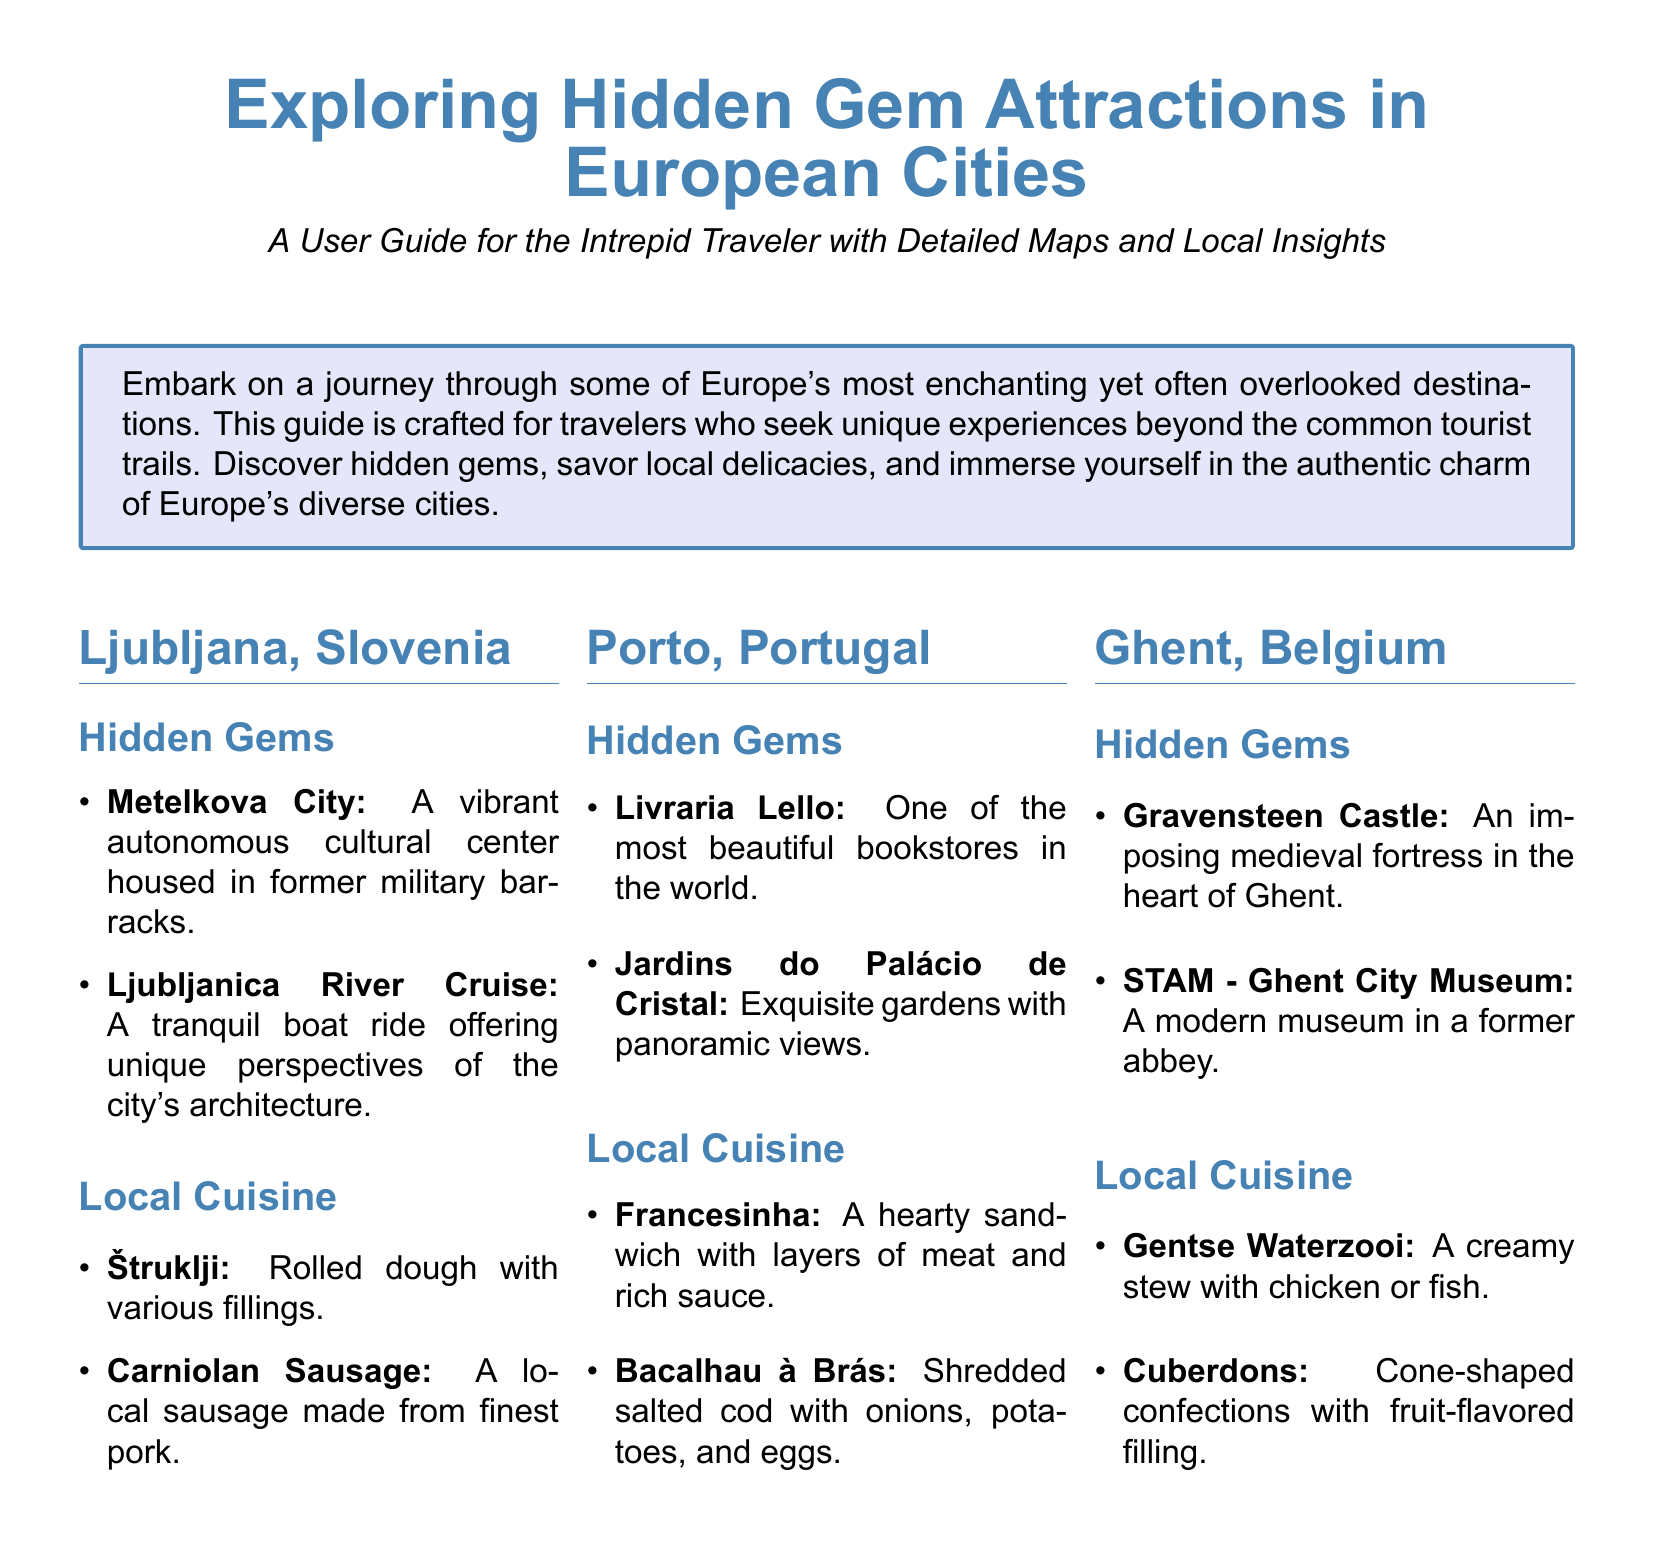What is the cultural center in Ljubljana? The document states that Metelkova City is a vibrant autonomous cultural center in Ljubljana.
Answer: Metelkova City What type of dish is Štruklji? Štruklji is described as rolled dough with various fillings.
Answer: Rolled dough What scenic feature does the Jardins do Palácio de Cristal in Porto offer? The document mentions that these gardens provide exquisite gardens with panoramic views.
Answer: Panoramic views Which medieval fortress is located in Ghent? Gravensteen Castle is identified as an imposing medieval fortress in the heart of Ghent.
Answer: Gravensteen Castle What unique dessert is mentioned as a local delicacy in Ghent? The document lists Cuberdons as cone-shaped confections with fruit-flavored filling.
Answer: Cuberdons Which Portuguese dish consists of layers of meat and rich sauce? The document tells us that Francesinha is a hearty sandwich with layers of meat and rich sauce.
Answer: Francesinha How many hidden gems are listed for Ljubljana? There are two hidden gems listed for Ljubljana according to the document: Metelkova City and Ljubljanica River Cruise.
Answer: Two What is the purpose of this user guide? The guide's purpose is crafted for travelers seeking unique experiences beyond common tourist trails.
Answer: Unique experiences 